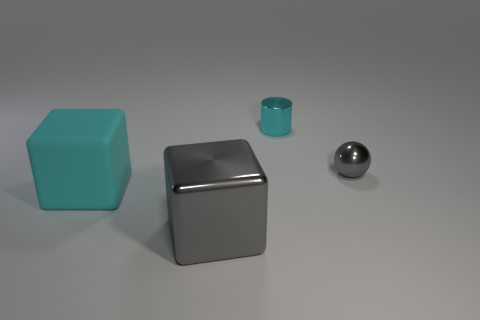How many small shiny cylinders are the same color as the matte object?
Provide a succinct answer. 1. What is the material of the big object that is the same color as the sphere?
Provide a succinct answer. Metal. Are the large gray block and the large cyan object made of the same material?
Give a very brief answer. No. There is a big gray thing; are there any gray things right of it?
Your answer should be very brief. Yes. There is a cyan object on the right side of the gray shiny thing on the left side of the cyan cylinder; what is it made of?
Keep it short and to the point. Metal. Does the big matte block have the same color as the metallic cylinder?
Ensure brevity in your answer.  Yes. What is the color of the thing that is both in front of the tiny cyan cylinder and to the right of the big shiny block?
Your answer should be compact. Gray. Does the gray metallic object in front of the rubber cube have the same size as the cyan cylinder?
Offer a very short reply. No. Is there anything else that has the same shape as the cyan metallic thing?
Provide a short and direct response. No. Does the tiny gray ball have the same material as the large cube in front of the rubber block?
Provide a short and direct response. Yes. 